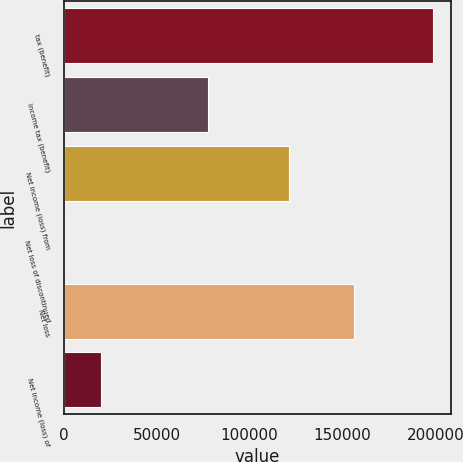Convert chart to OTSL. <chart><loc_0><loc_0><loc_500><loc_500><bar_chart><fcel>tax (benefit)<fcel>Income tax (benefit)<fcel>Net income (loss) from<fcel>Net loss of discontinued<fcel>Net loss<fcel>Net income (loss) of<nl><fcel>198619<fcel>77622<fcel>120997<fcel>0.11<fcel>156460<fcel>19862<nl></chart> 